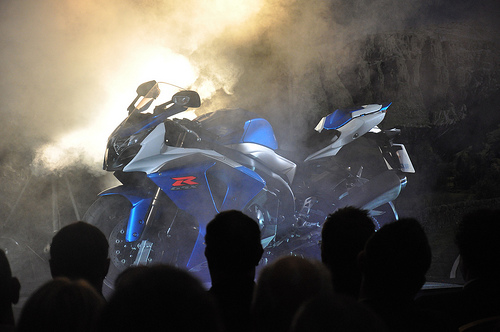<image>
Is the bike on the man? No. The bike is not positioned on the man. They may be near each other, but the bike is not supported by or resting on top of the man. 